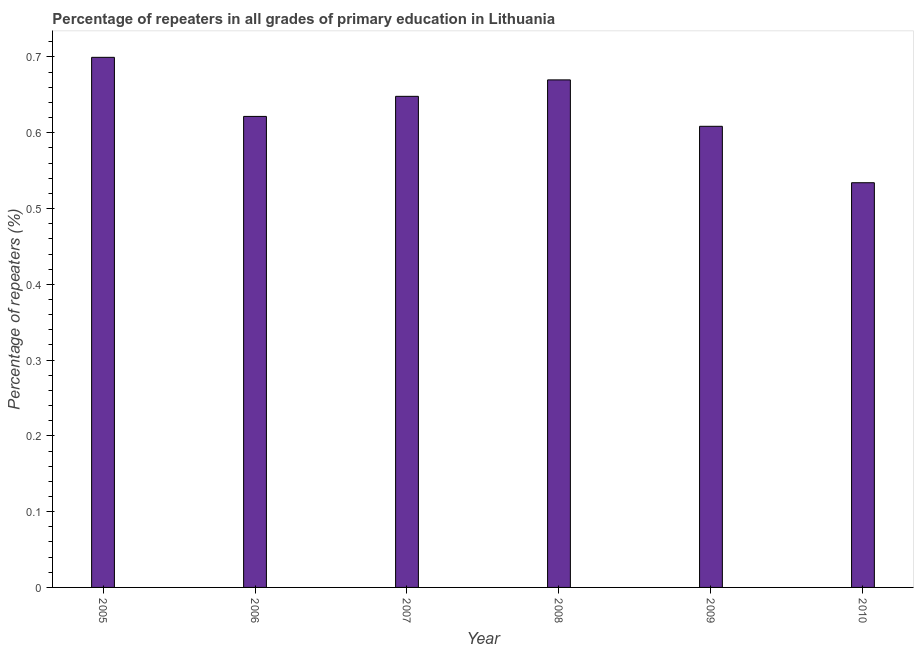Does the graph contain any zero values?
Provide a short and direct response. No. Does the graph contain grids?
Ensure brevity in your answer.  No. What is the title of the graph?
Ensure brevity in your answer.  Percentage of repeaters in all grades of primary education in Lithuania. What is the label or title of the X-axis?
Provide a succinct answer. Year. What is the label or title of the Y-axis?
Your response must be concise. Percentage of repeaters (%). What is the percentage of repeaters in primary education in 2008?
Your answer should be compact. 0.67. Across all years, what is the maximum percentage of repeaters in primary education?
Your response must be concise. 0.7. Across all years, what is the minimum percentage of repeaters in primary education?
Offer a very short reply. 0.53. In which year was the percentage of repeaters in primary education maximum?
Offer a very short reply. 2005. In which year was the percentage of repeaters in primary education minimum?
Ensure brevity in your answer.  2010. What is the sum of the percentage of repeaters in primary education?
Provide a succinct answer. 3.78. What is the difference between the percentage of repeaters in primary education in 2009 and 2010?
Offer a terse response. 0.07. What is the average percentage of repeaters in primary education per year?
Keep it short and to the point. 0.63. What is the median percentage of repeaters in primary education?
Make the answer very short. 0.63. Do a majority of the years between 2010 and 2005 (inclusive) have percentage of repeaters in primary education greater than 0.54 %?
Your answer should be very brief. Yes. What is the ratio of the percentage of repeaters in primary education in 2005 to that in 2010?
Your response must be concise. 1.31. Is the percentage of repeaters in primary education in 2007 less than that in 2008?
Your response must be concise. Yes. Is the difference between the percentage of repeaters in primary education in 2005 and 2008 greater than the difference between any two years?
Make the answer very short. No. What is the difference between the highest and the lowest percentage of repeaters in primary education?
Keep it short and to the point. 0.17. How many bars are there?
Your answer should be compact. 6. How many years are there in the graph?
Provide a short and direct response. 6. What is the difference between two consecutive major ticks on the Y-axis?
Your response must be concise. 0.1. Are the values on the major ticks of Y-axis written in scientific E-notation?
Offer a very short reply. No. What is the Percentage of repeaters (%) of 2005?
Make the answer very short. 0.7. What is the Percentage of repeaters (%) of 2006?
Make the answer very short. 0.62. What is the Percentage of repeaters (%) in 2007?
Provide a short and direct response. 0.65. What is the Percentage of repeaters (%) in 2008?
Provide a short and direct response. 0.67. What is the Percentage of repeaters (%) of 2009?
Your response must be concise. 0.61. What is the Percentage of repeaters (%) in 2010?
Your answer should be compact. 0.53. What is the difference between the Percentage of repeaters (%) in 2005 and 2006?
Keep it short and to the point. 0.08. What is the difference between the Percentage of repeaters (%) in 2005 and 2007?
Provide a succinct answer. 0.05. What is the difference between the Percentage of repeaters (%) in 2005 and 2008?
Provide a short and direct response. 0.03. What is the difference between the Percentage of repeaters (%) in 2005 and 2009?
Your response must be concise. 0.09. What is the difference between the Percentage of repeaters (%) in 2005 and 2010?
Your answer should be very brief. 0.17. What is the difference between the Percentage of repeaters (%) in 2006 and 2007?
Ensure brevity in your answer.  -0.03. What is the difference between the Percentage of repeaters (%) in 2006 and 2008?
Offer a very short reply. -0.05. What is the difference between the Percentage of repeaters (%) in 2006 and 2009?
Offer a terse response. 0.01. What is the difference between the Percentage of repeaters (%) in 2006 and 2010?
Offer a terse response. 0.09. What is the difference between the Percentage of repeaters (%) in 2007 and 2008?
Your answer should be very brief. -0.02. What is the difference between the Percentage of repeaters (%) in 2007 and 2009?
Provide a succinct answer. 0.04. What is the difference between the Percentage of repeaters (%) in 2007 and 2010?
Offer a very short reply. 0.11. What is the difference between the Percentage of repeaters (%) in 2008 and 2009?
Give a very brief answer. 0.06. What is the difference between the Percentage of repeaters (%) in 2008 and 2010?
Your answer should be compact. 0.14. What is the difference between the Percentage of repeaters (%) in 2009 and 2010?
Your response must be concise. 0.07. What is the ratio of the Percentage of repeaters (%) in 2005 to that in 2007?
Keep it short and to the point. 1.08. What is the ratio of the Percentage of repeaters (%) in 2005 to that in 2008?
Make the answer very short. 1.04. What is the ratio of the Percentage of repeaters (%) in 2005 to that in 2009?
Provide a succinct answer. 1.15. What is the ratio of the Percentage of repeaters (%) in 2005 to that in 2010?
Offer a very short reply. 1.31. What is the ratio of the Percentage of repeaters (%) in 2006 to that in 2007?
Your response must be concise. 0.96. What is the ratio of the Percentage of repeaters (%) in 2006 to that in 2008?
Your response must be concise. 0.93. What is the ratio of the Percentage of repeaters (%) in 2006 to that in 2009?
Provide a short and direct response. 1.02. What is the ratio of the Percentage of repeaters (%) in 2006 to that in 2010?
Ensure brevity in your answer.  1.16. What is the ratio of the Percentage of repeaters (%) in 2007 to that in 2009?
Offer a very short reply. 1.06. What is the ratio of the Percentage of repeaters (%) in 2007 to that in 2010?
Offer a very short reply. 1.21. What is the ratio of the Percentage of repeaters (%) in 2008 to that in 2009?
Give a very brief answer. 1.1. What is the ratio of the Percentage of repeaters (%) in 2008 to that in 2010?
Offer a very short reply. 1.25. What is the ratio of the Percentage of repeaters (%) in 2009 to that in 2010?
Your response must be concise. 1.14. 